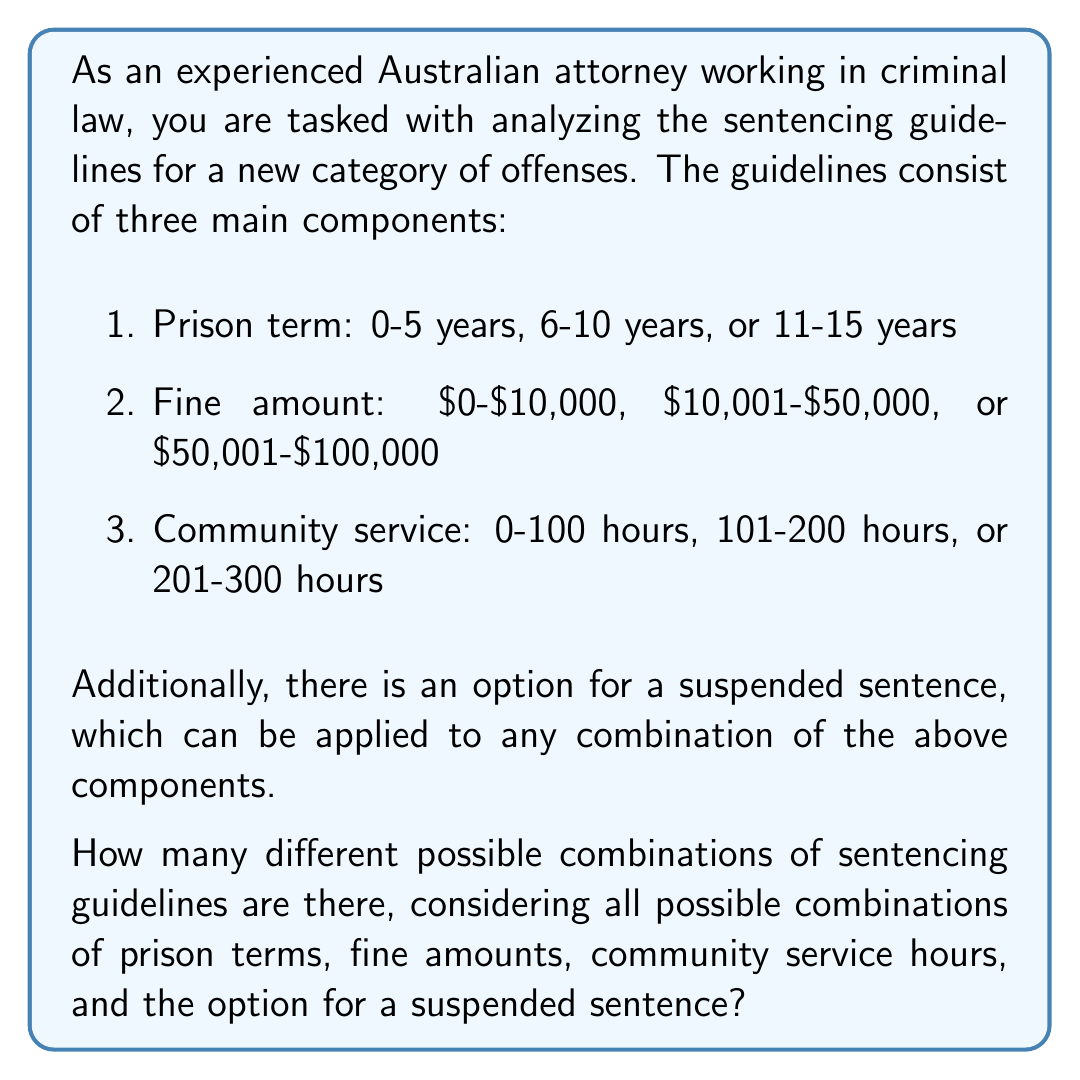Can you solve this math problem? To solve this problem, we need to use the multiplication principle of counting. We'll break down the problem into steps:

1. Count the number of options for each component:
   - Prison term: 3 options
   - Fine amount: 3 options
   - Community service: 3 options
   - Suspended sentence: 2 options (yes or no)

2. Apply the multiplication principle:
   The total number of combinations is the product of the number of options for each component.

   Let $C$ be the total number of combinations:

   $$C = 3 \times 3 \times 3 \times 2$$

3. Calculate the result:
   $$C = 3 \times 3 \times 3 \times 2 = 27 \times 2 = 54$$

Therefore, there are 54 different possible combinations of sentencing guidelines.

This approach ensures a strict application of the Rule of Law by considering all possible combinations systematically, allowing for consistent and fair sentencing across cases.
Answer: 54 possible combinations 